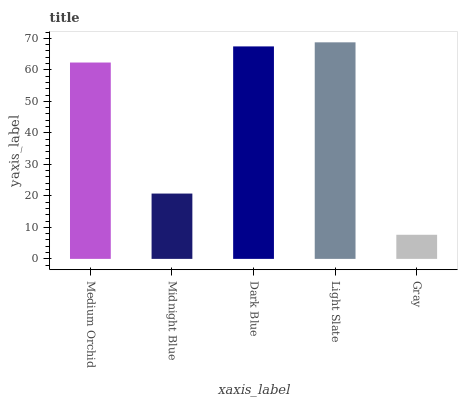Is Gray the minimum?
Answer yes or no. Yes. Is Light Slate the maximum?
Answer yes or no. Yes. Is Midnight Blue the minimum?
Answer yes or no. No. Is Midnight Blue the maximum?
Answer yes or no. No. Is Medium Orchid greater than Midnight Blue?
Answer yes or no. Yes. Is Midnight Blue less than Medium Orchid?
Answer yes or no. Yes. Is Midnight Blue greater than Medium Orchid?
Answer yes or no. No. Is Medium Orchid less than Midnight Blue?
Answer yes or no. No. Is Medium Orchid the high median?
Answer yes or no. Yes. Is Medium Orchid the low median?
Answer yes or no. Yes. Is Dark Blue the high median?
Answer yes or no. No. Is Light Slate the low median?
Answer yes or no. No. 